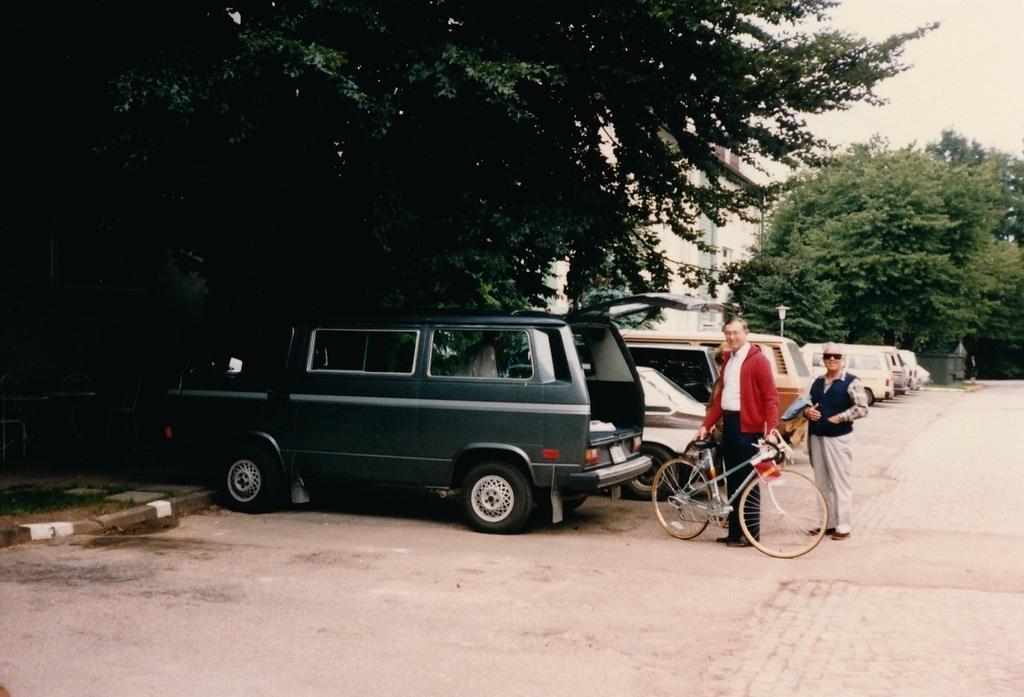In one or two sentences, can you explain what this image depicts? In the middle of this image, there are vehicles and two persons standing on a road. One of these two persons is holding a bicycle. In the background, there are trees, a building and there are clouds in the sky. 